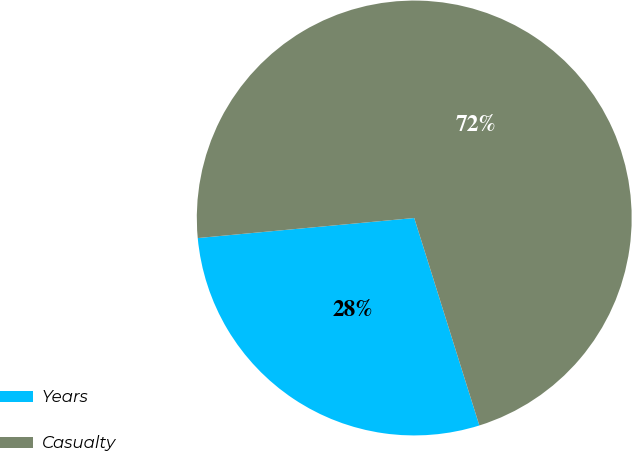<chart> <loc_0><loc_0><loc_500><loc_500><pie_chart><fcel>Years<fcel>Casualty<nl><fcel>28.37%<fcel>71.63%<nl></chart> 